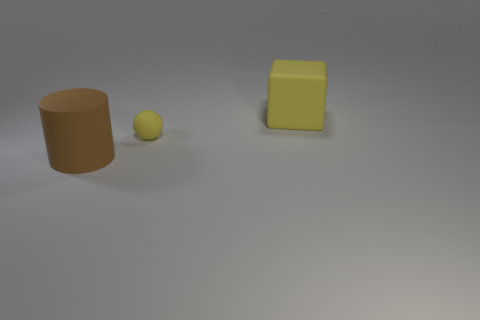Is there anything else that is the same size as the yellow rubber ball?
Your answer should be compact. No. There is a big object left of the object behind the matte sphere; what is its color?
Ensure brevity in your answer.  Brown. What is the color of the matte thing that is the same size as the cube?
Give a very brief answer. Brown. What number of large things are either metallic things or yellow matte spheres?
Provide a succinct answer. 0. Is the number of big objects in front of the matte ball greater than the number of cubes that are to the left of the large brown object?
Offer a very short reply. Yes. There is a thing that is the same color as the large block; what is its size?
Your response must be concise. Small. What number of other objects are there of the same size as the rubber cube?
Make the answer very short. 1. Does the big object that is to the left of the large yellow object have the same material as the large yellow object?
Provide a short and direct response. Yes. What number of other objects are the same color as the cylinder?
Your response must be concise. 0. What number of other objects are there of the same shape as the brown matte thing?
Your answer should be very brief. 0. 